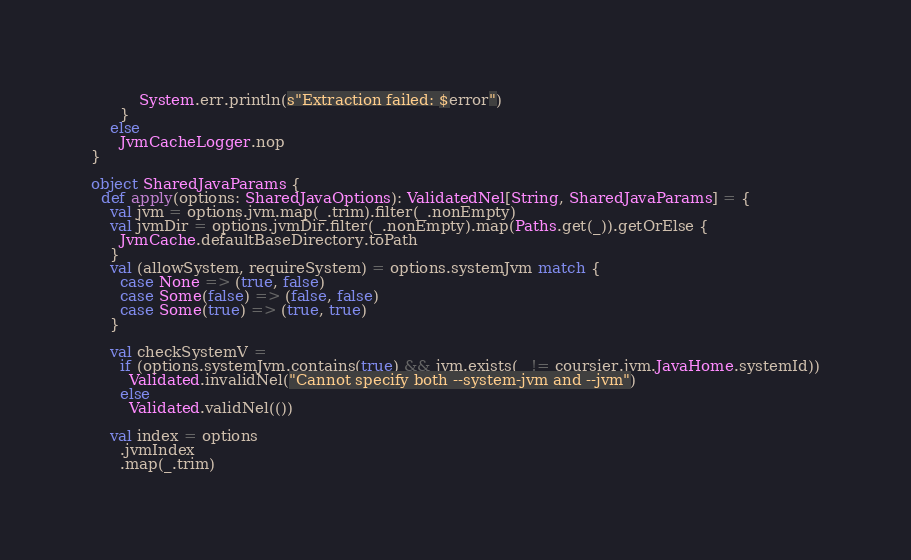<code> <loc_0><loc_0><loc_500><loc_500><_Scala_>          System.err.println(s"Extraction failed: $error")
      }
    else
      JvmCacheLogger.nop
}

object SharedJavaParams {
  def apply(options: SharedJavaOptions): ValidatedNel[String, SharedJavaParams] = {
    val jvm = options.jvm.map(_.trim).filter(_.nonEmpty)
    val jvmDir = options.jvmDir.filter(_.nonEmpty).map(Paths.get(_)).getOrElse {
      JvmCache.defaultBaseDirectory.toPath
    }
    val (allowSystem, requireSystem) = options.systemJvm match {
      case None => (true, false)
      case Some(false) => (false, false)
      case Some(true) => (true, true)
    }

    val checkSystemV =
      if (options.systemJvm.contains(true) && jvm.exists(_ != coursier.jvm.JavaHome.systemId))
        Validated.invalidNel("Cannot specify both --system-jvm and --jvm")
      else
        Validated.validNel(())

    val index = options
      .jvmIndex
      .map(_.trim)</code> 